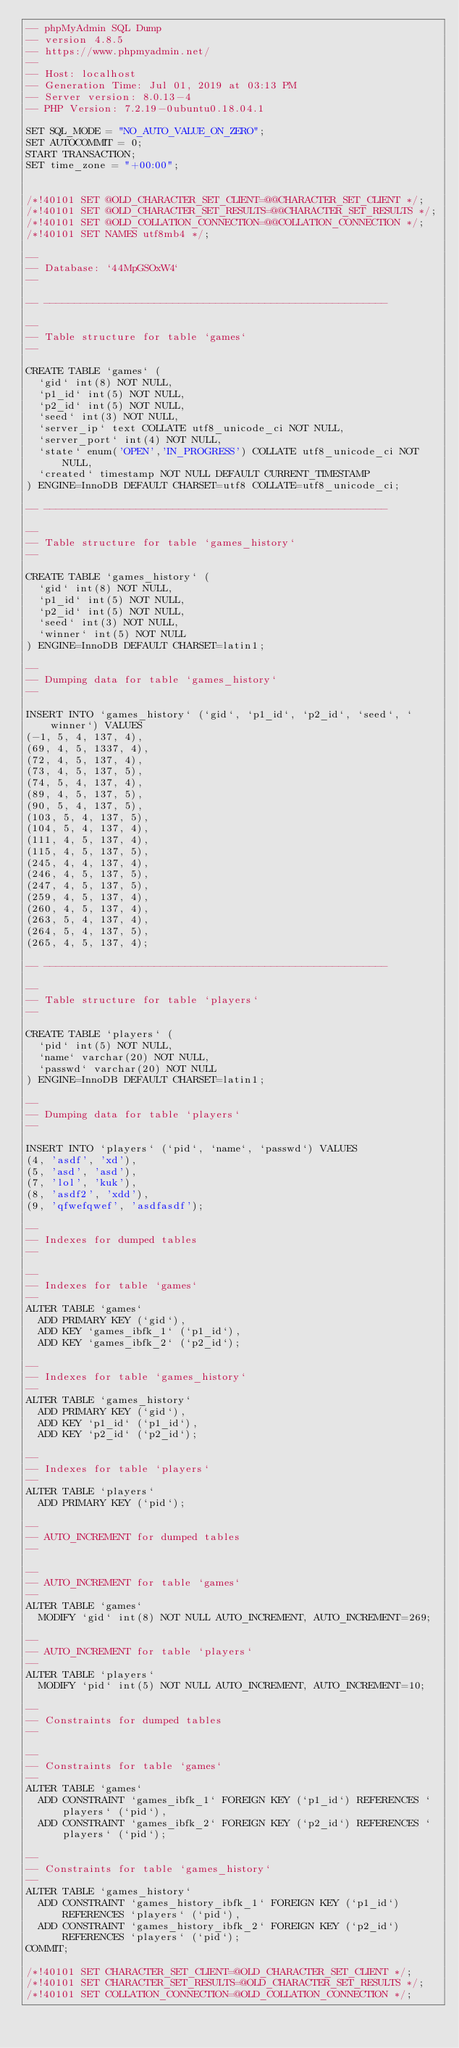Convert code to text. <code><loc_0><loc_0><loc_500><loc_500><_SQL_>-- phpMyAdmin SQL Dump
-- version 4.8.5
-- https://www.phpmyadmin.net/
--
-- Host: localhost
-- Generation Time: Jul 01, 2019 at 03:13 PM
-- Server version: 8.0.13-4
-- PHP Version: 7.2.19-0ubuntu0.18.04.1

SET SQL_MODE = "NO_AUTO_VALUE_ON_ZERO";
SET AUTOCOMMIT = 0;
START TRANSACTION;
SET time_zone = "+00:00";


/*!40101 SET @OLD_CHARACTER_SET_CLIENT=@@CHARACTER_SET_CLIENT */;
/*!40101 SET @OLD_CHARACTER_SET_RESULTS=@@CHARACTER_SET_RESULTS */;
/*!40101 SET @OLD_COLLATION_CONNECTION=@@COLLATION_CONNECTION */;
/*!40101 SET NAMES utf8mb4 */;

--
-- Database: `44MpGSOxW4`
--

-- --------------------------------------------------------

--
-- Table structure for table `games`
--

CREATE TABLE `games` (
  `gid` int(8) NOT NULL,
  `p1_id` int(5) NOT NULL,
  `p2_id` int(5) NOT NULL,
  `seed` int(3) NOT NULL,
  `server_ip` text COLLATE utf8_unicode_ci NOT NULL,
  `server_port` int(4) NOT NULL,
  `state` enum('OPEN','IN_PROGRESS') COLLATE utf8_unicode_ci NOT NULL,
  `created` timestamp NOT NULL DEFAULT CURRENT_TIMESTAMP
) ENGINE=InnoDB DEFAULT CHARSET=utf8 COLLATE=utf8_unicode_ci;

-- --------------------------------------------------------

--
-- Table structure for table `games_history`
--

CREATE TABLE `games_history` (
  `gid` int(8) NOT NULL,
  `p1_id` int(5) NOT NULL,
  `p2_id` int(5) NOT NULL,
  `seed` int(3) NOT NULL,
  `winner` int(5) NOT NULL
) ENGINE=InnoDB DEFAULT CHARSET=latin1;

--
-- Dumping data for table `games_history`
--

INSERT INTO `games_history` (`gid`, `p1_id`, `p2_id`, `seed`, `winner`) VALUES
(-1, 5, 4, 137, 4),
(69, 4, 5, 1337, 4),
(72, 4, 5, 137, 4),
(73, 4, 5, 137, 5),
(74, 5, 4, 137, 4),
(89, 4, 5, 137, 5),
(90, 5, 4, 137, 5),
(103, 5, 4, 137, 5),
(104, 5, 4, 137, 4),
(111, 4, 5, 137, 4),
(115, 4, 5, 137, 5),
(245, 4, 4, 137, 4),
(246, 4, 5, 137, 5),
(247, 4, 5, 137, 5),
(259, 4, 5, 137, 4),
(260, 4, 5, 137, 4),
(263, 5, 4, 137, 4),
(264, 5, 4, 137, 5),
(265, 4, 5, 137, 4);

-- --------------------------------------------------------

--
-- Table structure for table `players`
--

CREATE TABLE `players` (
  `pid` int(5) NOT NULL,
  `name` varchar(20) NOT NULL,
  `passwd` varchar(20) NOT NULL
) ENGINE=InnoDB DEFAULT CHARSET=latin1;

--
-- Dumping data for table `players`
--

INSERT INTO `players` (`pid`, `name`, `passwd`) VALUES
(4, 'asdf', 'xd'),
(5, 'asd', 'asd'),
(7, 'lol', 'kuk'),
(8, 'asdf2', 'xdd'),
(9, 'qfwefqwef', 'asdfasdf');

--
-- Indexes for dumped tables
--

--
-- Indexes for table `games`
--
ALTER TABLE `games`
  ADD PRIMARY KEY (`gid`),
  ADD KEY `games_ibfk_1` (`p1_id`),
  ADD KEY `games_ibfk_2` (`p2_id`);

--
-- Indexes for table `games_history`
--
ALTER TABLE `games_history`
  ADD PRIMARY KEY (`gid`),
  ADD KEY `p1_id` (`p1_id`),
  ADD KEY `p2_id` (`p2_id`);

--
-- Indexes for table `players`
--
ALTER TABLE `players`
  ADD PRIMARY KEY (`pid`);

--
-- AUTO_INCREMENT for dumped tables
--

--
-- AUTO_INCREMENT for table `games`
--
ALTER TABLE `games`
  MODIFY `gid` int(8) NOT NULL AUTO_INCREMENT, AUTO_INCREMENT=269;

--
-- AUTO_INCREMENT for table `players`
--
ALTER TABLE `players`
  MODIFY `pid` int(5) NOT NULL AUTO_INCREMENT, AUTO_INCREMENT=10;

--
-- Constraints for dumped tables
--

--
-- Constraints for table `games`
--
ALTER TABLE `games`
  ADD CONSTRAINT `games_ibfk_1` FOREIGN KEY (`p1_id`) REFERENCES `players` (`pid`),
  ADD CONSTRAINT `games_ibfk_2` FOREIGN KEY (`p2_id`) REFERENCES `players` (`pid`);

--
-- Constraints for table `games_history`
--
ALTER TABLE `games_history`
  ADD CONSTRAINT `games_history_ibfk_1` FOREIGN KEY (`p1_id`) REFERENCES `players` (`pid`),
  ADD CONSTRAINT `games_history_ibfk_2` FOREIGN KEY (`p2_id`) REFERENCES `players` (`pid`);
COMMIT;

/*!40101 SET CHARACTER_SET_CLIENT=@OLD_CHARACTER_SET_CLIENT */;
/*!40101 SET CHARACTER_SET_RESULTS=@OLD_CHARACTER_SET_RESULTS */;
/*!40101 SET COLLATION_CONNECTION=@OLD_COLLATION_CONNECTION */;
</code> 